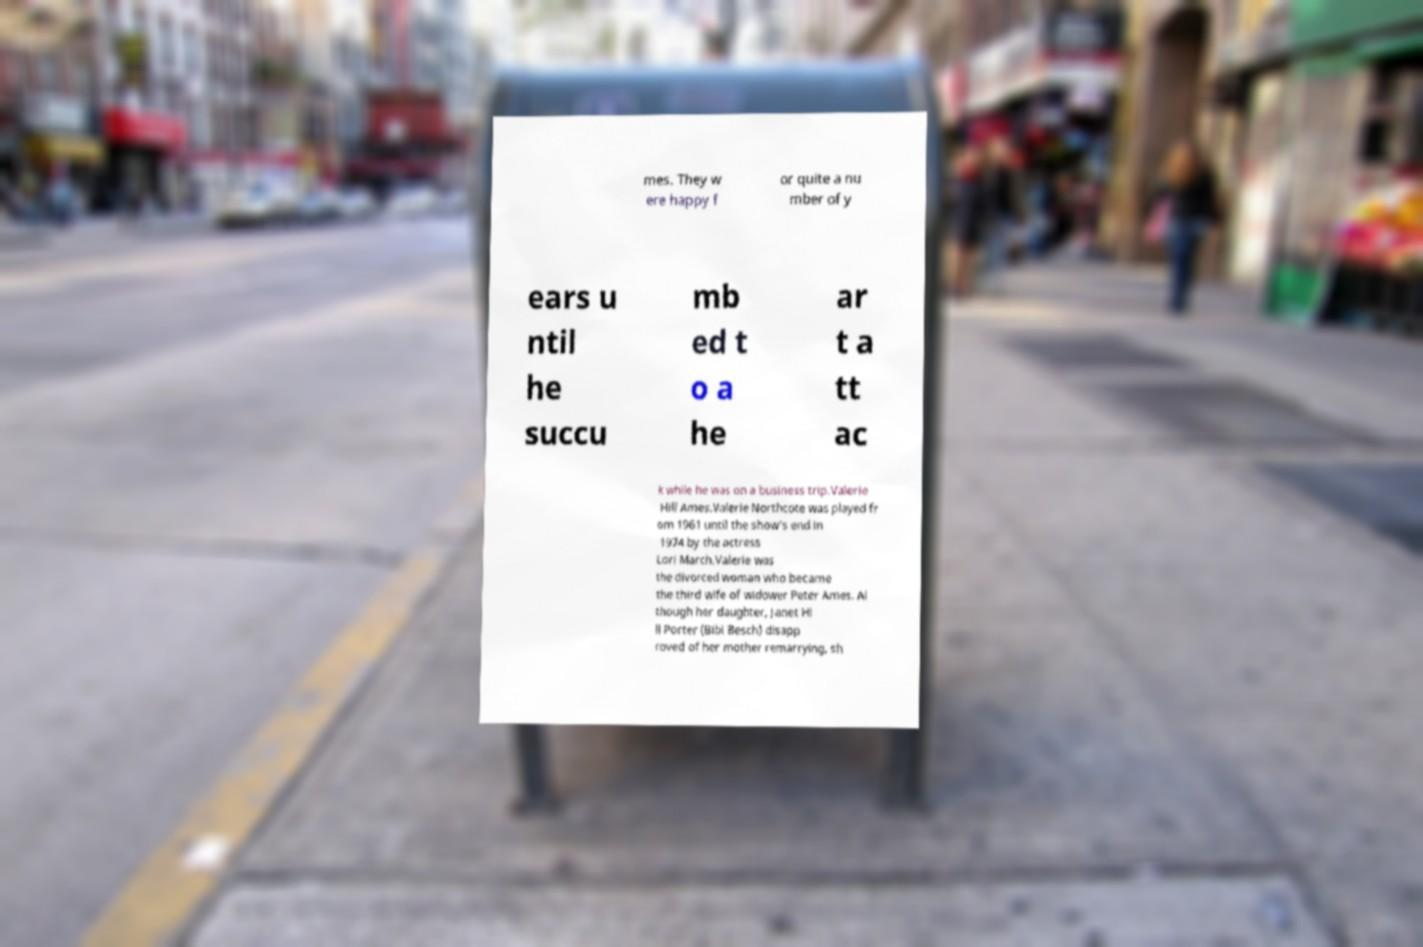Please identify and transcribe the text found in this image. mes. They w ere happy f or quite a nu mber of y ears u ntil he succu mb ed t o a he ar t a tt ac k while he was on a business trip.Valerie Hill Ames.Valerie Northcote was played fr om 1961 until the show's end in 1974 by the actress Lori March.Valerie was the divorced woman who became the third wife of widower Peter Ames. Al though her daughter, Janet Hi ll Porter (Bibi Besch) disapp roved of her mother remarrying, sh 